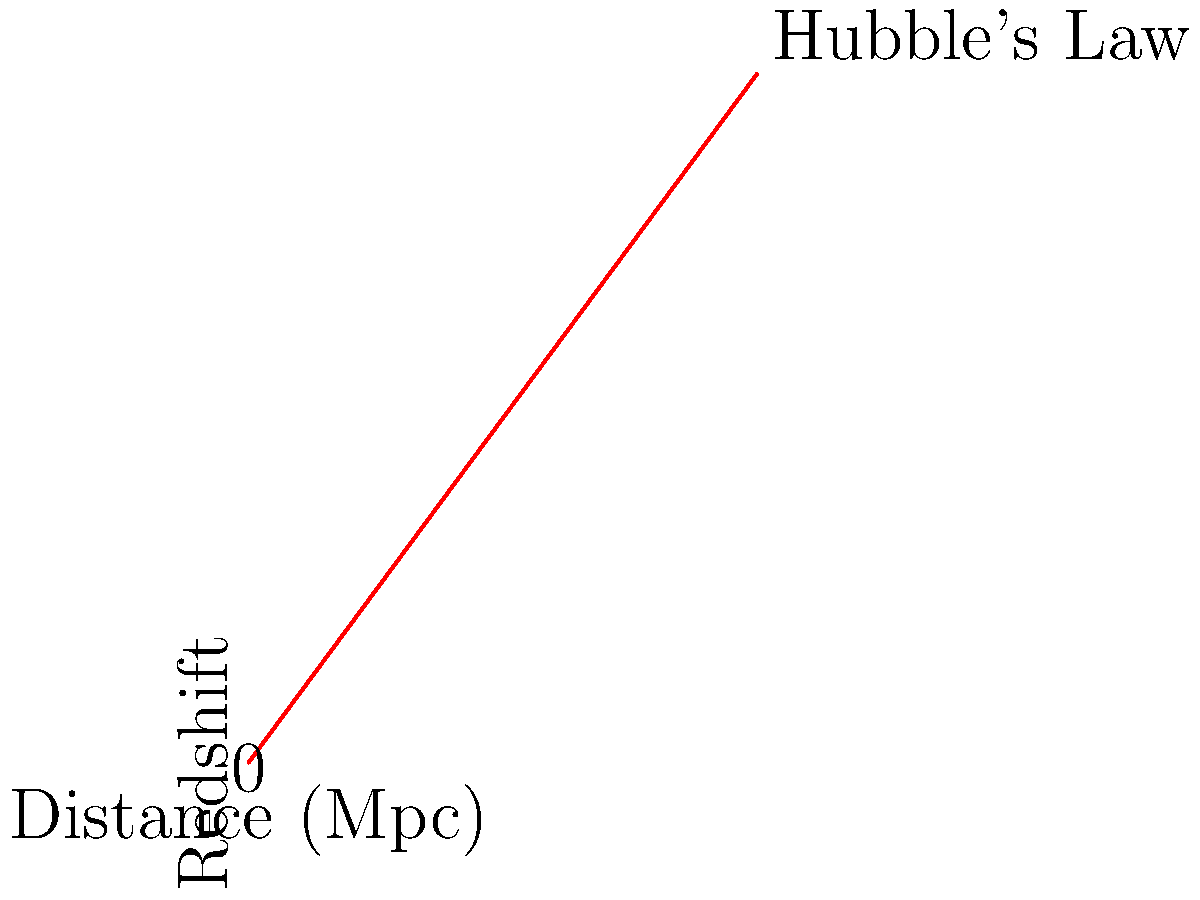Based on the graph showing the relationship between redshift and distance for distant galaxies, what does the slope of the line represent in the context of the expanding universe? To understand what the slope represents, let's break down the graph and its implications:

1. The x-axis represents the distance to galaxies in megaparsecs (Mpc).
2. The y-axis represents the redshift observed for these galaxies.
3. The linear relationship between redshift and distance is known as Hubble's Law.

Now, let's analyze the slope:

4. The slope of the line is given by the equation:
   $$ \text{slope} = \frac{\text{change in y}}{\text{change in x}} = \frac{\text{change in redshift}}{\text{change in distance}} $$

5. In the context of the expanding universe, redshift is related to the recession velocity of galaxies. The relationship is given by:
   $$ z \approx \frac{v}{c} $$
   where $z$ is the redshift, $v$ is the recession velocity, and $c$ is the speed of light.

6. Hubble's Law states that the recession velocity is proportional to distance:
   $$ v = H_0 \times d $$
   where $H_0$ is the Hubble constant and $d$ is the distance.

7. Combining these relationships, we can see that:
   $$ \frac{\text{redshift}}{\text{distance}} \approx \frac{v}{cd} = \frac{H_0}{c} $$

8. Therefore, the slope of the line in the graph represents $\frac{H_0}{c}$, where $H_0$ is the Hubble constant.

9. The Hubble constant $H_0$ is a measure of the current expansion rate of the universe.

Thus, the slope of the line in the redshift vs. distance graph is directly related to the Hubble constant and represents the expansion rate of the universe.
Answer: The Hubble constant (expansion rate of the universe) 